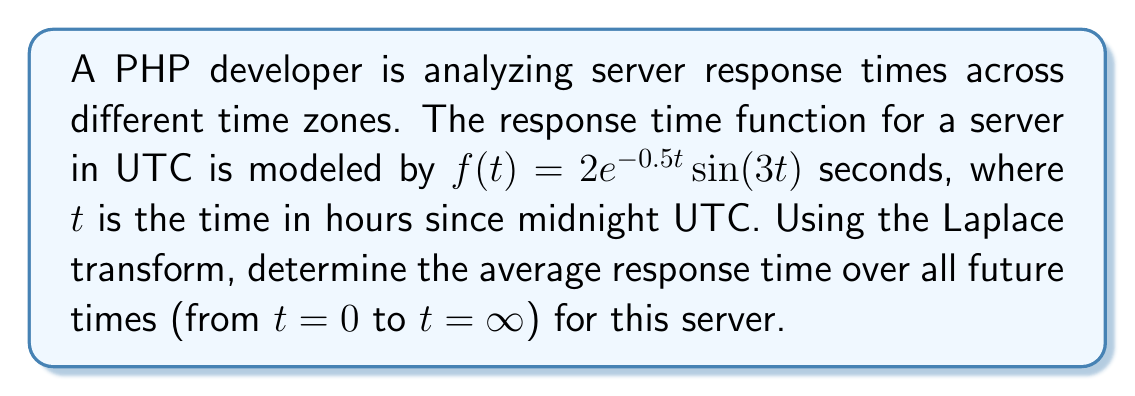Solve this math problem. To solve this problem, we'll follow these steps:

1) The Laplace transform of $f(t)$ is given by:

   $$F(s) = \mathcal{L}\{f(t)\} = \int_0^\infty f(t)e^{-st}dt$$

2) For $f(t) = 2e^{-0.5t}\sin(3t)$, we can use the Laplace transform property:

   $$\mathcal{L}\{e^{at}\sin(bt)\} = \frac{b}{(s-a)^2 + b^2}$$

3) In our case, $a = -0.5$ and $b = 3$. So:

   $$F(s) = 2 \cdot \frac{3}{(s+0.5)^2 + 3^2} = \frac{6}{(s+0.5)^2 + 9}$$

4) The average value of $f(t)$ over all future times is given by:

   $$\lim_{s \to 0} sF(s) = \lim_{s \to 0} s \cdot \frac{6}{(s+0.5)^2 + 9}$$

5) Evaluating this limit:

   $$\lim_{s \to 0} \frac{6s}{(s+0.5)^2 + 9} = \frac{6 \cdot 0}{(0+0.5)^2 + 9} = \frac{0}{9.25} = 0$$

6) Therefore, the average response time over all future times is 0 seconds.
Answer: 0 seconds 